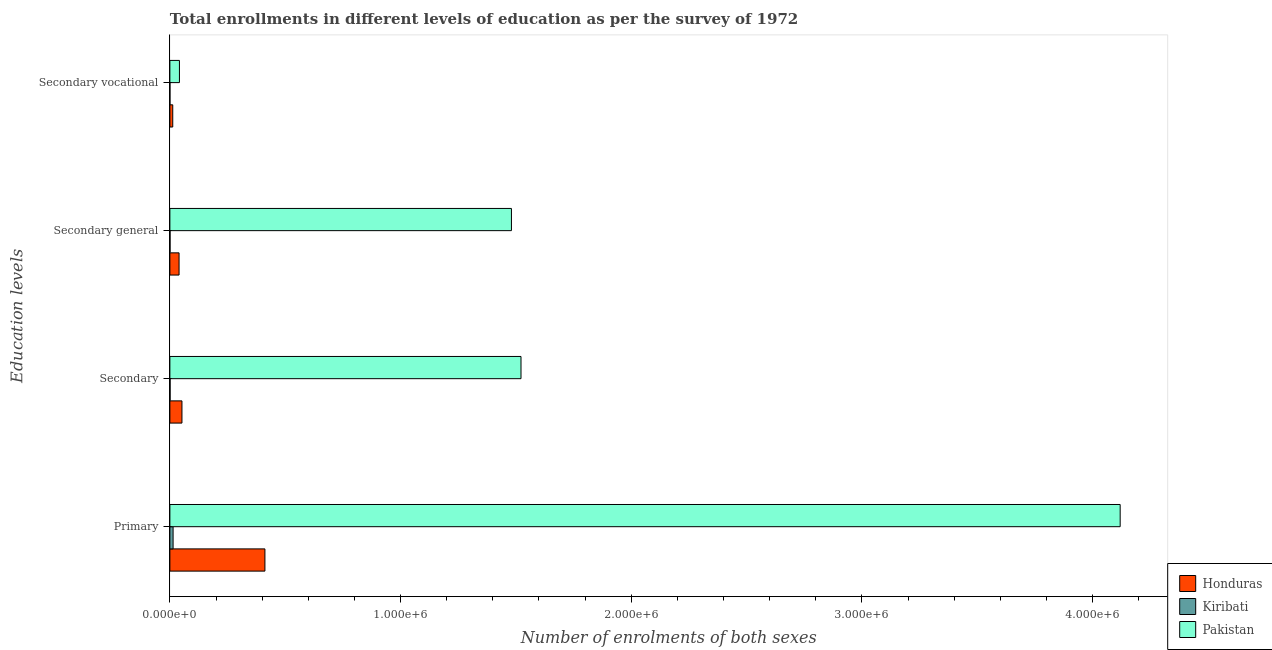How many different coloured bars are there?
Make the answer very short. 3. Are the number of bars per tick equal to the number of legend labels?
Your answer should be compact. Yes. Are the number of bars on each tick of the Y-axis equal?
Give a very brief answer. Yes. What is the label of the 1st group of bars from the top?
Keep it short and to the point. Secondary vocational. What is the number of enrolments in secondary general education in Pakistan?
Your answer should be compact. 1.48e+06. Across all countries, what is the maximum number of enrolments in primary education?
Keep it short and to the point. 4.12e+06. Across all countries, what is the minimum number of enrolments in secondary general education?
Provide a short and direct response. 704. In which country was the number of enrolments in secondary vocational education minimum?
Keep it short and to the point. Kiribati. What is the total number of enrolments in secondary vocational education in the graph?
Give a very brief answer. 5.42e+04. What is the difference between the number of enrolments in secondary vocational education in Pakistan and that in Honduras?
Your response must be concise. 2.90e+04. What is the difference between the number of enrolments in secondary education in Pakistan and the number of enrolments in primary education in Honduras?
Offer a very short reply. 1.11e+06. What is the average number of enrolments in secondary general education per country?
Provide a short and direct response. 5.07e+05. What is the difference between the number of enrolments in secondary vocational education and number of enrolments in primary education in Kiribati?
Provide a short and direct response. -1.37e+04. What is the ratio of the number of enrolments in secondary vocational education in Kiribati to that in Pakistan?
Provide a short and direct response. 0.01. Is the difference between the number of enrolments in secondary general education in Pakistan and Honduras greater than the difference between the number of enrolments in secondary education in Pakistan and Honduras?
Provide a short and direct response. No. What is the difference between the highest and the second highest number of enrolments in primary education?
Ensure brevity in your answer.  3.71e+06. What is the difference between the highest and the lowest number of enrolments in primary education?
Ensure brevity in your answer.  4.11e+06. In how many countries, is the number of enrolments in secondary education greater than the average number of enrolments in secondary education taken over all countries?
Offer a terse response. 1. What does the 3rd bar from the top in Primary represents?
Provide a short and direct response. Honduras. What does the 1st bar from the bottom in Secondary general represents?
Provide a short and direct response. Honduras. Is it the case that in every country, the sum of the number of enrolments in primary education and number of enrolments in secondary education is greater than the number of enrolments in secondary general education?
Give a very brief answer. Yes. How many countries are there in the graph?
Your answer should be very brief. 3. Does the graph contain any zero values?
Offer a very short reply. No. Does the graph contain grids?
Keep it short and to the point. No. How many legend labels are there?
Provide a short and direct response. 3. How are the legend labels stacked?
Offer a very short reply. Vertical. What is the title of the graph?
Ensure brevity in your answer.  Total enrollments in different levels of education as per the survey of 1972. Does "Gabon" appear as one of the legend labels in the graph?
Ensure brevity in your answer.  No. What is the label or title of the X-axis?
Offer a very short reply. Number of enrolments of both sexes. What is the label or title of the Y-axis?
Your answer should be compact. Education levels. What is the Number of enrolments of both sexes of Honduras in Primary?
Provide a short and direct response. 4.12e+05. What is the Number of enrolments of both sexes in Kiribati in Primary?
Your answer should be very brief. 1.40e+04. What is the Number of enrolments of both sexes of Pakistan in Primary?
Your answer should be very brief. 4.12e+06. What is the Number of enrolments of both sexes in Honduras in Secondary?
Keep it short and to the point. 5.23e+04. What is the Number of enrolments of both sexes in Kiribati in Secondary?
Offer a very short reply. 926. What is the Number of enrolments of both sexes of Pakistan in Secondary?
Your response must be concise. 1.52e+06. What is the Number of enrolments of both sexes of Honduras in Secondary general?
Offer a terse response. 3.99e+04. What is the Number of enrolments of both sexes of Kiribati in Secondary general?
Offer a terse response. 704. What is the Number of enrolments of both sexes of Pakistan in Secondary general?
Offer a very short reply. 1.48e+06. What is the Number of enrolments of both sexes of Honduras in Secondary vocational?
Give a very brief answer. 1.25e+04. What is the Number of enrolments of both sexes in Kiribati in Secondary vocational?
Provide a short and direct response. 222. What is the Number of enrolments of both sexes of Pakistan in Secondary vocational?
Keep it short and to the point. 4.15e+04. Across all Education levels, what is the maximum Number of enrolments of both sexes in Honduras?
Ensure brevity in your answer.  4.12e+05. Across all Education levels, what is the maximum Number of enrolments of both sexes of Kiribati?
Provide a short and direct response. 1.40e+04. Across all Education levels, what is the maximum Number of enrolments of both sexes in Pakistan?
Your answer should be compact. 4.12e+06. Across all Education levels, what is the minimum Number of enrolments of both sexes of Honduras?
Ensure brevity in your answer.  1.25e+04. Across all Education levels, what is the minimum Number of enrolments of both sexes in Kiribati?
Offer a terse response. 222. Across all Education levels, what is the minimum Number of enrolments of both sexes in Pakistan?
Give a very brief answer. 4.15e+04. What is the total Number of enrolments of both sexes of Honduras in the graph?
Offer a terse response. 5.17e+05. What is the total Number of enrolments of both sexes of Kiribati in the graph?
Give a very brief answer. 1.58e+04. What is the total Number of enrolments of both sexes in Pakistan in the graph?
Provide a short and direct response. 7.16e+06. What is the difference between the Number of enrolments of both sexes of Honduras in Primary and that in Secondary?
Keep it short and to the point. 3.60e+05. What is the difference between the Number of enrolments of both sexes of Kiribati in Primary and that in Secondary?
Offer a terse response. 1.30e+04. What is the difference between the Number of enrolments of both sexes in Pakistan in Primary and that in Secondary?
Make the answer very short. 2.60e+06. What is the difference between the Number of enrolments of both sexes of Honduras in Primary and that in Secondary general?
Your answer should be very brief. 3.72e+05. What is the difference between the Number of enrolments of both sexes in Kiribati in Primary and that in Secondary general?
Offer a very short reply. 1.33e+04. What is the difference between the Number of enrolments of both sexes in Pakistan in Primary and that in Secondary general?
Offer a terse response. 2.64e+06. What is the difference between the Number of enrolments of both sexes of Honduras in Primary and that in Secondary vocational?
Your answer should be very brief. 4.00e+05. What is the difference between the Number of enrolments of both sexes in Kiribati in Primary and that in Secondary vocational?
Keep it short and to the point. 1.37e+04. What is the difference between the Number of enrolments of both sexes of Pakistan in Primary and that in Secondary vocational?
Give a very brief answer. 4.08e+06. What is the difference between the Number of enrolments of both sexes in Honduras in Secondary and that in Secondary general?
Provide a short and direct response. 1.25e+04. What is the difference between the Number of enrolments of both sexes in Kiribati in Secondary and that in Secondary general?
Offer a terse response. 222. What is the difference between the Number of enrolments of both sexes of Pakistan in Secondary and that in Secondary general?
Offer a very short reply. 4.15e+04. What is the difference between the Number of enrolments of both sexes in Honduras in Secondary and that in Secondary vocational?
Your response must be concise. 3.99e+04. What is the difference between the Number of enrolments of both sexes in Kiribati in Secondary and that in Secondary vocational?
Make the answer very short. 704. What is the difference between the Number of enrolments of both sexes of Pakistan in Secondary and that in Secondary vocational?
Your answer should be very brief. 1.48e+06. What is the difference between the Number of enrolments of both sexes in Honduras in Secondary general and that in Secondary vocational?
Your response must be concise. 2.74e+04. What is the difference between the Number of enrolments of both sexes of Kiribati in Secondary general and that in Secondary vocational?
Offer a terse response. 482. What is the difference between the Number of enrolments of both sexes in Pakistan in Secondary general and that in Secondary vocational?
Make the answer very short. 1.44e+06. What is the difference between the Number of enrolments of both sexes in Honduras in Primary and the Number of enrolments of both sexes in Kiribati in Secondary?
Provide a short and direct response. 4.11e+05. What is the difference between the Number of enrolments of both sexes of Honduras in Primary and the Number of enrolments of both sexes of Pakistan in Secondary?
Your response must be concise. -1.11e+06. What is the difference between the Number of enrolments of both sexes in Kiribati in Primary and the Number of enrolments of both sexes in Pakistan in Secondary?
Offer a very short reply. -1.51e+06. What is the difference between the Number of enrolments of both sexes of Honduras in Primary and the Number of enrolments of both sexes of Kiribati in Secondary general?
Make the answer very short. 4.11e+05. What is the difference between the Number of enrolments of both sexes in Honduras in Primary and the Number of enrolments of both sexes in Pakistan in Secondary general?
Offer a terse response. -1.07e+06. What is the difference between the Number of enrolments of both sexes of Kiribati in Primary and the Number of enrolments of both sexes of Pakistan in Secondary general?
Offer a terse response. -1.47e+06. What is the difference between the Number of enrolments of both sexes of Honduras in Primary and the Number of enrolments of both sexes of Kiribati in Secondary vocational?
Offer a very short reply. 4.12e+05. What is the difference between the Number of enrolments of both sexes of Honduras in Primary and the Number of enrolments of both sexes of Pakistan in Secondary vocational?
Provide a short and direct response. 3.71e+05. What is the difference between the Number of enrolments of both sexes of Kiribati in Primary and the Number of enrolments of both sexes of Pakistan in Secondary vocational?
Offer a terse response. -2.75e+04. What is the difference between the Number of enrolments of both sexes of Honduras in Secondary and the Number of enrolments of both sexes of Kiribati in Secondary general?
Keep it short and to the point. 5.16e+04. What is the difference between the Number of enrolments of both sexes in Honduras in Secondary and the Number of enrolments of both sexes in Pakistan in Secondary general?
Your response must be concise. -1.43e+06. What is the difference between the Number of enrolments of both sexes in Kiribati in Secondary and the Number of enrolments of both sexes in Pakistan in Secondary general?
Your answer should be very brief. -1.48e+06. What is the difference between the Number of enrolments of both sexes in Honduras in Secondary and the Number of enrolments of both sexes in Kiribati in Secondary vocational?
Provide a succinct answer. 5.21e+04. What is the difference between the Number of enrolments of both sexes of Honduras in Secondary and the Number of enrolments of both sexes of Pakistan in Secondary vocational?
Offer a very short reply. 1.08e+04. What is the difference between the Number of enrolments of both sexes in Kiribati in Secondary and the Number of enrolments of both sexes in Pakistan in Secondary vocational?
Offer a terse response. -4.06e+04. What is the difference between the Number of enrolments of both sexes of Honduras in Secondary general and the Number of enrolments of both sexes of Kiribati in Secondary vocational?
Your answer should be compact. 3.96e+04. What is the difference between the Number of enrolments of both sexes of Honduras in Secondary general and the Number of enrolments of both sexes of Pakistan in Secondary vocational?
Provide a short and direct response. -1619. What is the difference between the Number of enrolments of both sexes of Kiribati in Secondary general and the Number of enrolments of both sexes of Pakistan in Secondary vocational?
Ensure brevity in your answer.  -4.08e+04. What is the average Number of enrolments of both sexes in Honduras per Education levels?
Ensure brevity in your answer.  1.29e+05. What is the average Number of enrolments of both sexes of Kiribati per Education levels?
Provide a succinct answer. 3953.5. What is the average Number of enrolments of both sexes of Pakistan per Education levels?
Offer a very short reply. 1.79e+06. What is the difference between the Number of enrolments of both sexes of Honduras and Number of enrolments of both sexes of Kiribati in Primary?
Give a very brief answer. 3.98e+05. What is the difference between the Number of enrolments of both sexes of Honduras and Number of enrolments of both sexes of Pakistan in Primary?
Your answer should be very brief. -3.71e+06. What is the difference between the Number of enrolments of both sexes of Kiribati and Number of enrolments of both sexes of Pakistan in Primary?
Your answer should be very brief. -4.11e+06. What is the difference between the Number of enrolments of both sexes in Honduras and Number of enrolments of both sexes in Kiribati in Secondary?
Ensure brevity in your answer.  5.14e+04. What is the difference between the Number of enrolments of both sexes in Honduras and Number of enrolments of both sexes in Pakistan in Secondary?
Provide a short and direct response. -1.47e+06. What is the difference between the Number of enrolments of both sexes of Kiribati and Number of enrolments of both sexes of Pakistan in Secondary?
Your response must be concise. -1.52e+06. What is the difference between the Number of enrolments of both sexes in Honduras and Number of enrolments of both sexes in Kiribati in Secondary general?
Provide a short and direct response. 3.92e+04. What is the difference between the Number of enrolments of both sexes of Honduras and Number of enrolments of both sexes of Pakistan in Secondary general?
Your answer should be very brief. -1.44e+06. What is the difference between the Number of enrolments of both sexes in Kiribati and Number of enrolments of both sexes in Pakistan in Secondary general?
Your answer should be very brief. -1.48e+06. What is the difference between the Number of enrolments of both sexes of Honduras and Number of enrolments of both sexes of Kiribati in Secondary vocational?
Provide a short and direct response. 1.22e+04. What is the difference between the Number of enrolments of both sexes of Honduras and Number of enrolments of both sexes of Pakistan in Secondary vocational?
Give a very brief answer. -2.90e+04. What is the difference between the Number of enrolments of both sexes in Kiribati and Number of enrolments of both sexes in Pakistan in Secondary vocational?
Your answer should be compact. -4.13e+04. What is the ratio of the Number of enrolments of both sexes in Honduras in Primary to that in Secondary?
Keep it short and to the point. 7.87. What is the ratio of the Number of enrolments of both sexes of Kiribati in Primary to that in Secondary?
Offer a terse response. 15.08. What is the ratio of the Number of enrolments of both sexes in Pakistan in Primary to that in Secondary?
Your response must be concise. 2.71. What is the ratio of the Number of enrolments of both sexes of Honduras in Primary to that in Secondary general?
Ensure brevity in your answer.  10.34. What is the ratio of the Number of enrolments of both sexes of Kiribati in Primary to that in Secondary general?
Give a very brief answer. 19.83. What is the ratio of the Number of enrolments of both sexes in Pakistan in Primary to that in Secondary general?
Your answer should be compact. 2.78. What is the ratio of the Number of enrolments of both sexes of Honduras in Primary to that in Secondary vocational?
Your answer should be very brief. 33.05. What is the ratio of the Number of enrolments of both sexes of Kiribati in Primary to that in Secondary vocational?
Give a very brief answer. 62.89. What is the ratio of the Number of enrolments of both sexes of Pakistan in Primary to that in Secondary vocational?
Your answer should be compact. 99.32. What is the ratio of the Number of enrolments of both sexes in Honduras in Secondary to that in Secondary general?
Make the answer very short. 1.31. What is the ratio of the Number of enrolments of both sexes of Kiribati in Secondary to that in Secondary general?
Keep it short and to the point. 1.32. What is the ratio of the Number of enrolments of both sexes of Pakistan in Secondary to that in Secondary general?
Your answer should be very brief. 1.03. What is the ratio of the Number of enrolments of both sexes in Honduras in Secondary to that in Secondary vocational?
Ensure brevity in your answer.  4.2. What is the ratio of the Number of enrolments of both sexes of Kiribati in Secondary to that in Secondary vocational?
Ensure brevity in your answer.  4.17. What is the ratio of the Number of enrolments of both sexes in Pakistan in Secondary to that in Secondary vocational?
Make the answer very short. 36.7. What is the ratio of the Number of enrolments of both sexes of Honduras in Secondary general to that in Secondary vocational?
Provide a short and direct response. 3.2. What is the ratio of the Number of enrolments of both sexes of Kiribati in Secondary general to that in Secondary vocational?
Make the answer very short. 3.17. What is the ratio of the Number of enrolments of both sexes of Pakistan in Secondary general to that in Secondary vocational?
Keep it short and to the point. 35.7. What is the difference between the highest and the second highest Number of enrolments of both sexes in Honduras?
Keep it short and to the point. 3.60e+05. What is the difference between the highest and the second highest Number of enrolments of both sexes in Kiribati?
Offer a very short reply. 1.30e+04. What is the difference between the highest and the second highest Number of enrolments of both sexes in Pakistan?
Your answer should be compact. 2.60e+06. What is the difference between the highest and the lowest Number of enrolments of both sexes in Honduras?
Ensure brevity in your answer.  4.00e+05. What is the difference between the highest and the lowest Number of enrolments of both sexes in Kiribati?
Your answer should be compact. 1.37e+04. What is the difference between the highest and the lowest Number of enrolments of both sexes in Pakistan?
Provide a succinct answer. 4.08e+06. 